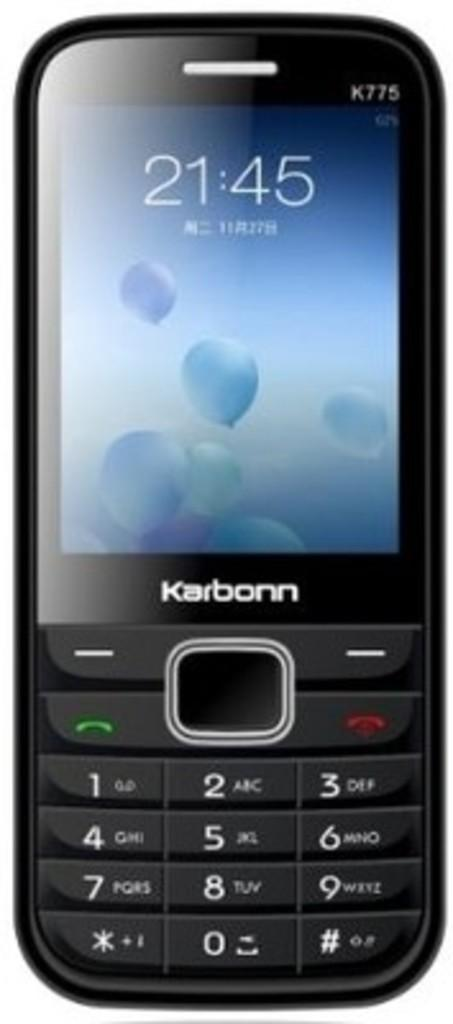<image>
Create a compact narrative representing the image presented. A Karbonn phone shows that the time is 21:45. 